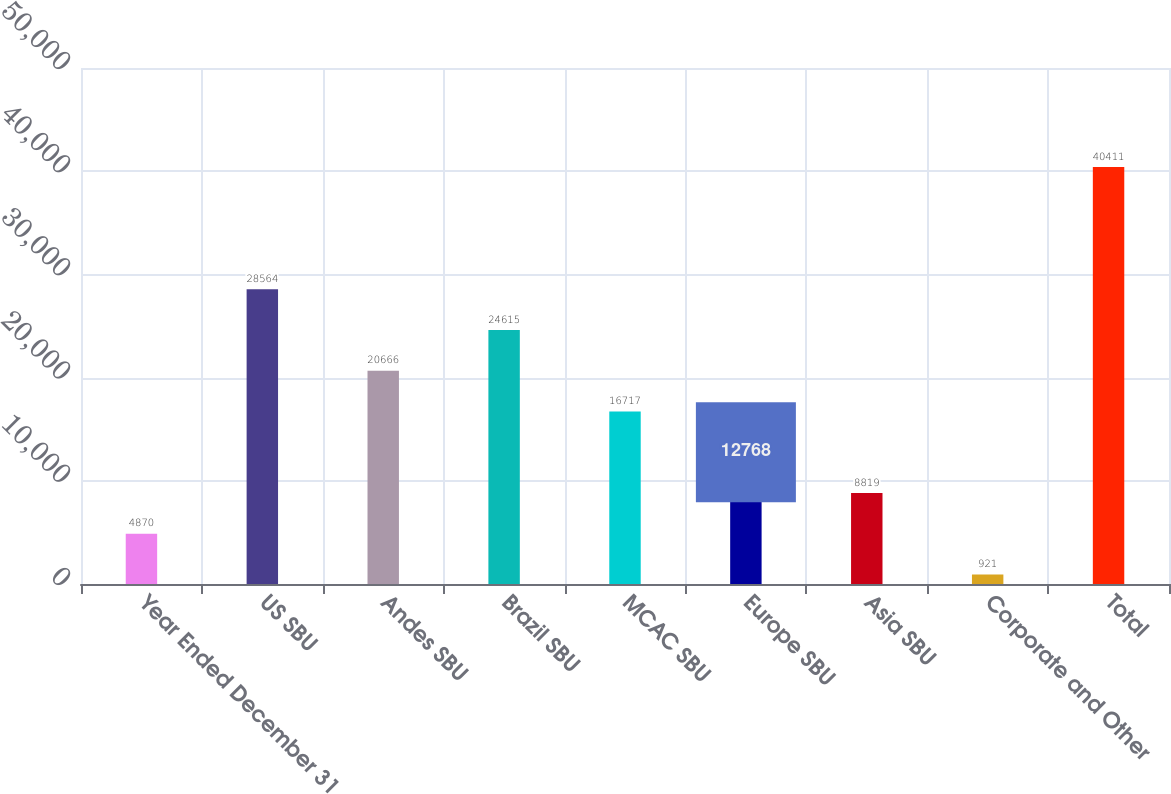<chart> <loc_0><loc_0><loc_500><loc_500><bar_chart><fcel>Year Ended December 31<fcel>US SBU<fcel>Andes SBU<fcel>Brazil SBU<fcel>MCAC SBU<fcel>Europe SBU<fcel>Asia SBU<fcel>Corporate and Other<fcel>Total<nl><fcel>4870<fcel>28564<fcel>20666<fcel>24615<fcel>16717<fcel>12768<fcel>8819<fcel>921<fcel>40411<nl></chart> 